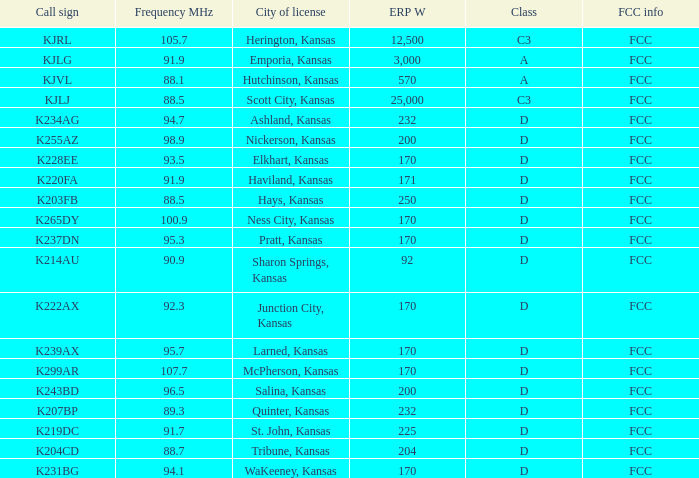What average erp w did the 8 204.0. I'm looking to parse the entire table for insights. Could you assist me with that? {'header': ['Call sign', 'Frequency MHz', 'City of license', 'ERP W', 'Class', 'FCC info'], 'rows': [['KJRL', '105.7', 'Herington, Kansas', '12,500', 'C3', 'FCC'], ['KJLG', '91.9', 'Emporia, Kansas', '3,000', 'A', 'FCC'], ['KJVL', '88.1', 'Hutchinson, Kansas', '570', 'A', 'FCC'], ['KJLJ', '88.5', 'Scott City, Kansas', '25,000', 'C3', 'FCC'], ['K234AG', '94.7', 'Ashland, Kansas', '232', 'D', 'FCC'], ['K255AZ', '98.9', 'Nickerson, Kansas', '200', 'D', 'FCC'], ['K228EE', '93.5', 'Elkhart, Kansas', '170', 'D', 'FCC'], ['K220FA', '91.9', 'Haviland, Kansas', '171', 'D', 'FCC'], ['K203FB', '88.5', 'Hays, Kansas', '250', 'D', 'FCC'], ['K265DY', '100.9', 'Ness City, Kansas', '170', 'D', 'FCC'], ['K237DN', '95.3', 'Pratt, Kansas', '170', 'D', 'FCC'], ['K214AU', '90.9', 'Sharon Springs, Kansas', '92', 'D', 'FCC'], ['K222AX', '92.3', 'Junction City, Kansas', '170', 'D', 'FCC'], ['K239AX', '95.7', 'Larned, Kansas', '170', 'D', 'FCC'], ['K299AR', '107.7', 'McPherson, Kansas', '170', 'D', 'FCC'], ['K243BD', '96.5', 'Salina, Kansas', '200', 'D', 'FCC'], ['K207BP', '89.3', 'Quinter, Kansas', '232', 'D', 'FCC'], ['K219DC', '91.7', 'St. John, Kansas', '225', 'D', 'FCC'], ['K204CD', '88.7', 'Tribune, Kansas', '204', 'D', 'FCC'], ['K231BG', '94.1', 'WaKeeney, Kansas', '170', 'D', 'FCC']]} 